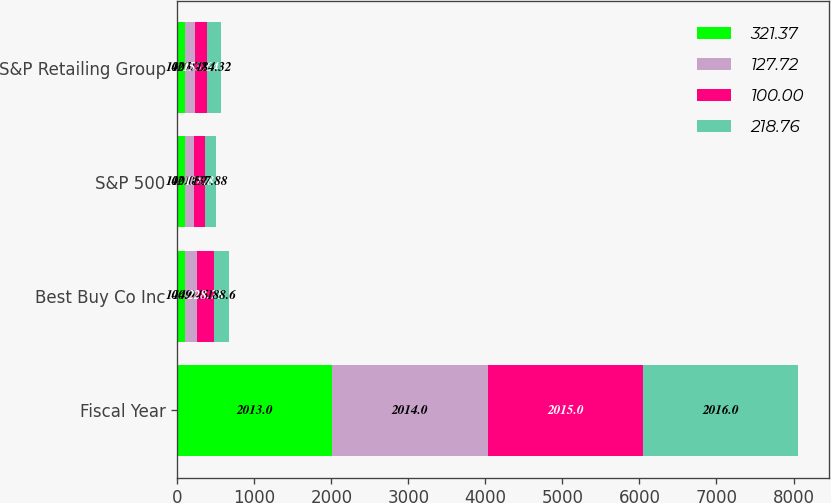Convert chart. <chart><loc_0><loc_0><loc_500><loc_500><stacked_bar_chart><ecel><fcel>Fiscal Year<fcel>Best Buy Co Inc<fcel>S&P 500<fcel>S&P Retailing Group<nl><fcel>321.37<fcel>2013<fcel>100<fcel>100<fcel>100<nl><fcel>127.72<fcel>2014<fcel>149.45<fcel>121.52<fcel>127.72<nl><fcel>100<fcel>2015<fcel>228.78<fcel>138.8<fcel>153.64<nl><fcel>218.76<fcel>2016<fcel>188.6<fcel>137.88<fcel>184.32<nl></chart> 